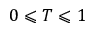Convert formula to latex. <formula><loc_0><loc_0><loc_500><loc_500>0 \leqslant T \leqslant 1</formula> 